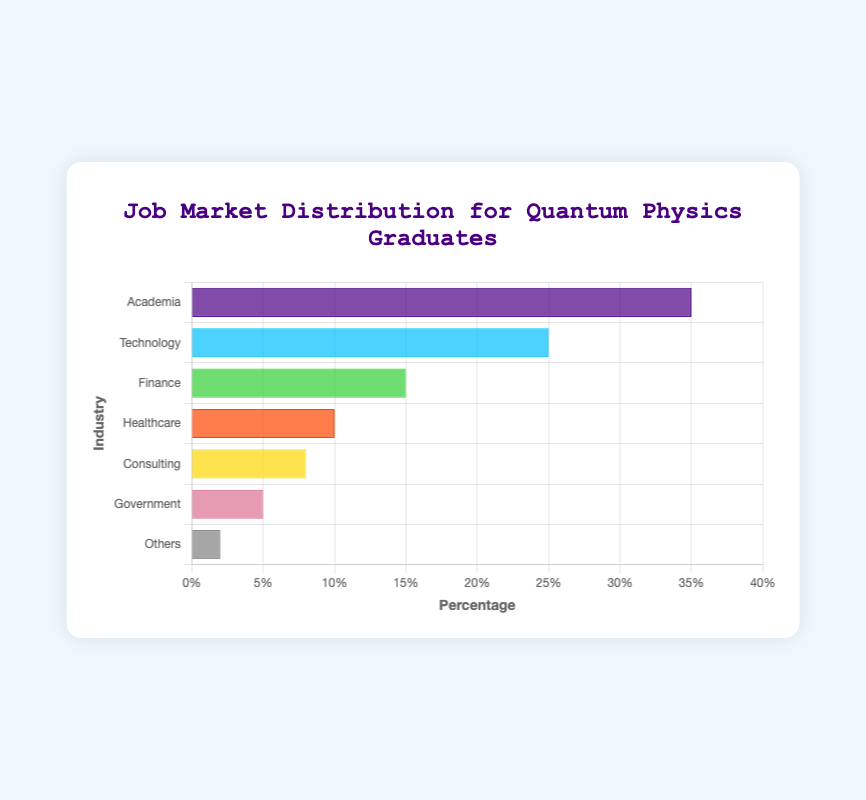Which industry employs the highest percentage of Quantum Physics graduates? According to the chart, the industry with the tallest bar represents the highest percentage of graduates. The tallest bar corresponds to Academia.
Answer: Academia What is the combined percentage of Quantum Physics graduates working in Technology and Finance? To find the combined percentage, add the percentages of Technology and Finance: 25% (Technology) + 15% (Finance) = 40%.
Answer: 40% Which industries employ fewer than 10% of Quantum Physics graduates each? By observing the lengths of the bars and their corresponding values, Consulting (8%), Government (5%), and Others (2%) each have percentages below 10%.
Answer: Consulting, Government, Others What is the difference in the percentage of graduates between the Technology and Healthcare industries? The percentage for Technology is 25% and for Healthcare is 10%. Subtract Healthcare's percentage from Technology's: 25% - 10% = 15%.
Answer: 15% Is the percentage of graduates in Academia more than twice the percentage in Healthcare? Graduates in Academia constitute 35%, and in Healthcare, they constitute 10%. Check if 35% is more than twice the 10% of Healthcare: 2 * 10% = 20%. Since 35% > 20%, the statement is true.
Answer: Yes Arrange the industries in descending order of percentage of Quantum Physics graduates employed. List the percentages in descending order: 35% (Academia), 25% (Technology), 15% (Finance), 10% (Healthcare), 8% (Consulting), 5% (Government), 2% (Others).
Answer: Academia, Technology, Finance, Healthcare, Consulting, Government, Others What is the average percentage of graduates working in Finance, Healthcare, and Consulting combined? Add the percentages of Finance, Healthcare, and Consulting, then divide by the number of categories: (15% + 10% + 8%) / 3 = 33% / 3 = 11%.
Answer: 11% How many more percent of graduates work in Academia compared to Government? Subtract the percentage of graduates in Government from the percentage in Academia: 35% (Academia) - 5% (Government) = 30%.
Answer: 30% What is the percentage difference between the smallest and largest industries by employment? The smallest industry is Others with 2% and the largest is Academia with 35%. Subtract the smallest from the largest: 35% - 2% = 33%.
Answer: 33% Which industry has the shortest bar in the chart? The industry with the shortest bar represents the smallest percentage, which corresponds to Others with 2%.
Answer: Others 